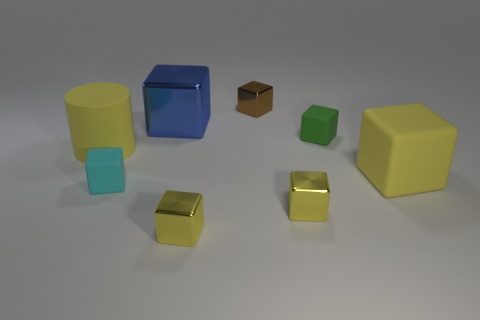If I were to group these objects based on their attributes, what categories could I create? You could categorize these objects based on several attributes, such as color, size, and material. For instance, one category might be 'blue objects', which would include the big cylinder and the large cube. Another could be 'small cubes', which the brown and metallic cubes would fall into. In terms of materials, there's a mix that could include 'reflective objects', like the big cylinder and large cube, and 'matte-finished objects', such as the wooden cube. 